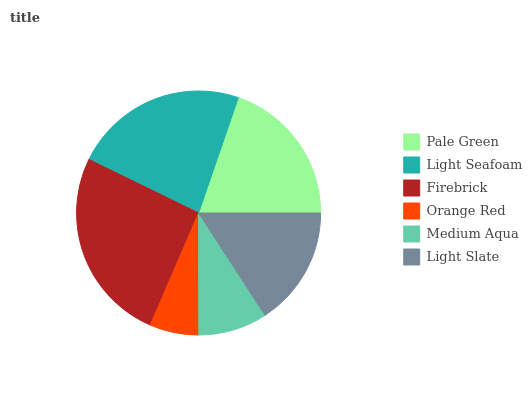Is Orange Red the minimum?
Answer yes or no. Yes. Is Firebrick the maximum?
Answer yes or no. Yes. Is Light Seafoam the minimum?
Answer yes or no. No. Is Light Seafoam the maximum?
Answer yes or no. No. Is Light Seafoam greater than Pale Green?
Answer yes or no. Yes. Is Pale Green less than Light Seafoam?
Answer yes or no. Yes. Is Pale Green greater than Light Seafoam?
Answer yes or no. No. Is Light Seafoam less than Pale Green?
Answer yes or no. No. Is Pale Green the high median?
Answer yes or no. Yes. Is Light Slate the low median?
Answer yes or no. Yes. Is Firebrick the high median?
Answer yes or no. No. Is Medium Aqua the low median?
Answer yes or no. No. 